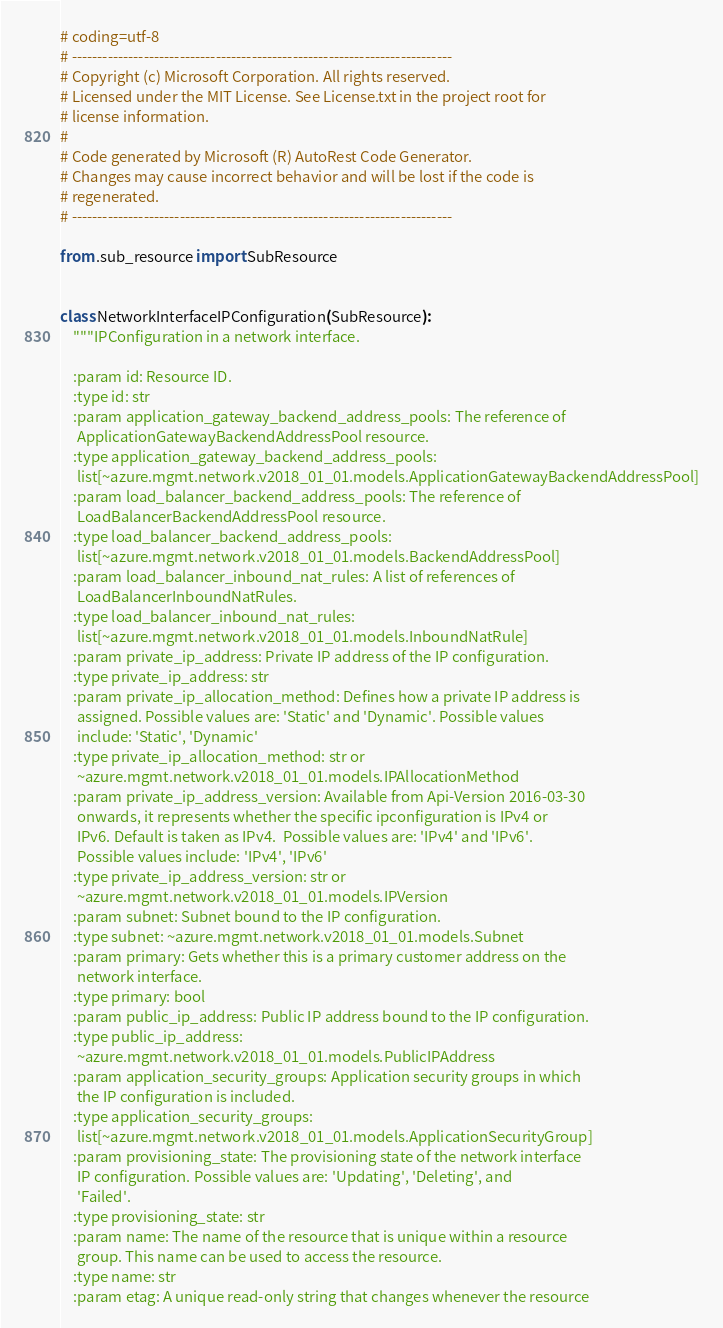<code> <loc_0><loc_0><loc_500><loc_500><_Python_># coding=utf-8
# --------------------------------------------------------------------------
# Copyright (c) Microsoft Corporation. All rights reserved.
# Licensed under the MIT License. See License.txt in the project root for
# license information.
#
# Code generated by Microsoft (R) AutoRest Code Generator.
# Changes may cause incorrect behavior and will be lost if the code is
# regenerated.
# --------------------------------------------------------------------------

from .sub_resource import SubResource


class NetworkInterfaceIPConfiguration(SubResource):
    """IPConfiguration in a network interface.

    :param id: Resource ID.
    :type id: str
    :param application_gateway_backend_address_pools: The reference of
     ApplicationGatewayBackendAddressPool resource.
    :type application_gateway_backend_address_pools:
     list[~azure.mgmt.network.v2018_01_01.models.ApplicationGatewayBackendAddressPool]
    :param load_balancer_backend_address_pools: The reference of
     LoadBalancerBackendAddressPool resource.
    :type load_balancer_backend_address_pools:
     list[~azure.mgmt.network.v2018_01_01.models.BackendAddressPool]
    :param load_balancer_inbound_nat_rules: A list of references of
     LoadBalancerInboundNatRules.
    :type load_balancer_inbound_nat_rules:
     list[~azure.mgmt.network.v2018_01_01.models.InboundNatRule]
    :param private_ip_address: Private IP address of the IP configuration.
    :type private_ip_address: str
    :param private_ip_allocation_method: Defines how a private IP address is
     assigned. Possible values are: 'Static' and 'Dynamic'. Possible values
     include: 'Static', 'Dynamic'
    :type private_ip_allocation_method: str or
     ~azure.mgmt.network.v2018_01_01.models.IPAllocationMethod
    :param private_ip_address_version: Available from Api-Version 2016-03-30
     onwards, it represents whether the specific ipconfiguration is IPv4 or
     IPv6. Default is taken as IPv4.  Possible values are: 'IPv4' and 'IPv6'.
     Possible values include: 'IPv4', 'IPv6'
    :type private_ip_address_version: str or
     ~azure.mgmt.network.v2018_01_01.models.IPVersion
    :param subnet: Subnet bound to the IP configuration.
    :type subnet: ~azure.mgmt.network.v2018_01_01.models.Subnet
    :param primary: Gets whether this is a primary customer address on the
     network interface.
    :type primary: bool
    :param public_ip_address: Public IP address bound to the IP configuration.
    :type public_ip_address:
     ~azure.mgmt.network.v2018_01_01.models.PublicIPAddress
    :param application_security_groups: Application security groups in which
     the IP configuration is included.
    :type application_security_groups:
     list[~azure.mgmt.network.v2018_01_01.models.ApplicationSecurityGroup]
    :param provisioning_state: The provisioning state of the network interface
     IP configuration. Possible values are: 'Updating', 'Deleting', and
     'Failed'.
    :type provisioning_state: str
    :param name: The name of the resource that is unique within a resource
     group. This name can be used to access the resource.
    :type name: str
    :param etag: A unique read-only string that changes whenever the resource</code> 